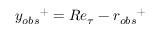Convert formula to latex. <formula><loc_0><loc_0><loc_500><loc_500>{ y _ { o b s } } ^ { + } = R e _ { \tau } - { r _ { o b s } } ^ { + }</formula> 